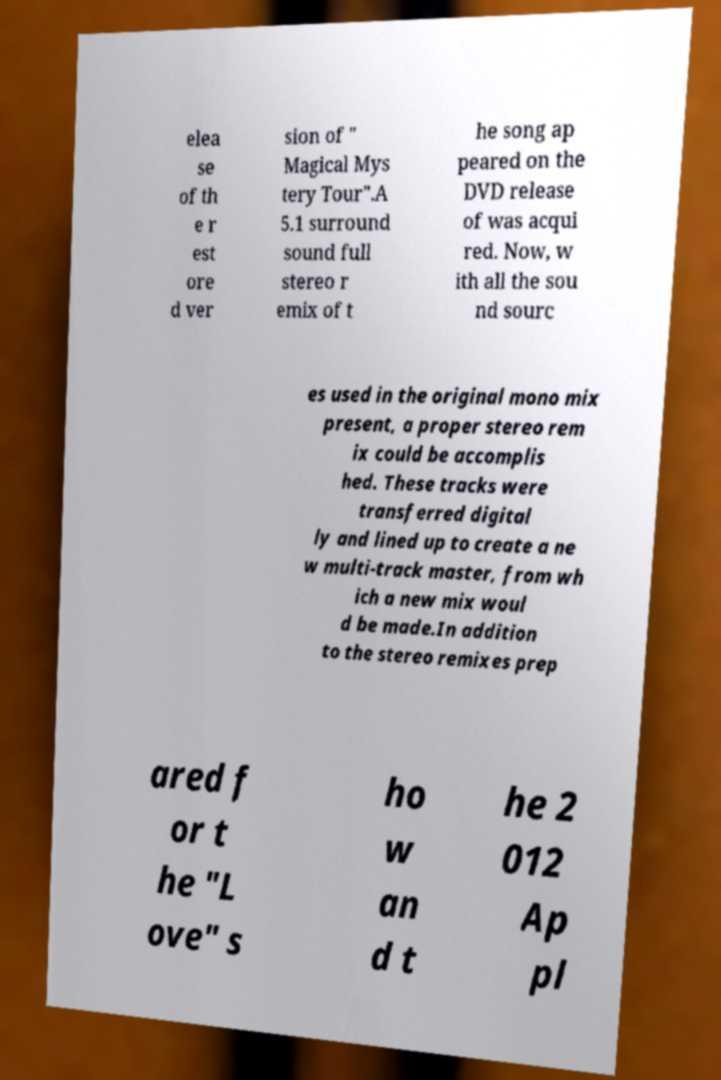I need the written content from this picture converted into text. Can you do that? elea se of th e r est ore d ver sion of " Magical Mys tery Tour".A 5.1 surround sound full stereo r emix of t he song ap peared on the DVD release of was acqui red. Now, w ith all the sou nd sourc es used in the original mono mix present, a proper stereo rem ix could be accomplis hed. These tracks were transferred digital ly and lined up to create a ne w multi-track master, from wh ich a new mix woul d be made.In addition to the stereo remixes prep ared f or t he "L ove" s ho w an d t he 2 012 Ap pl 